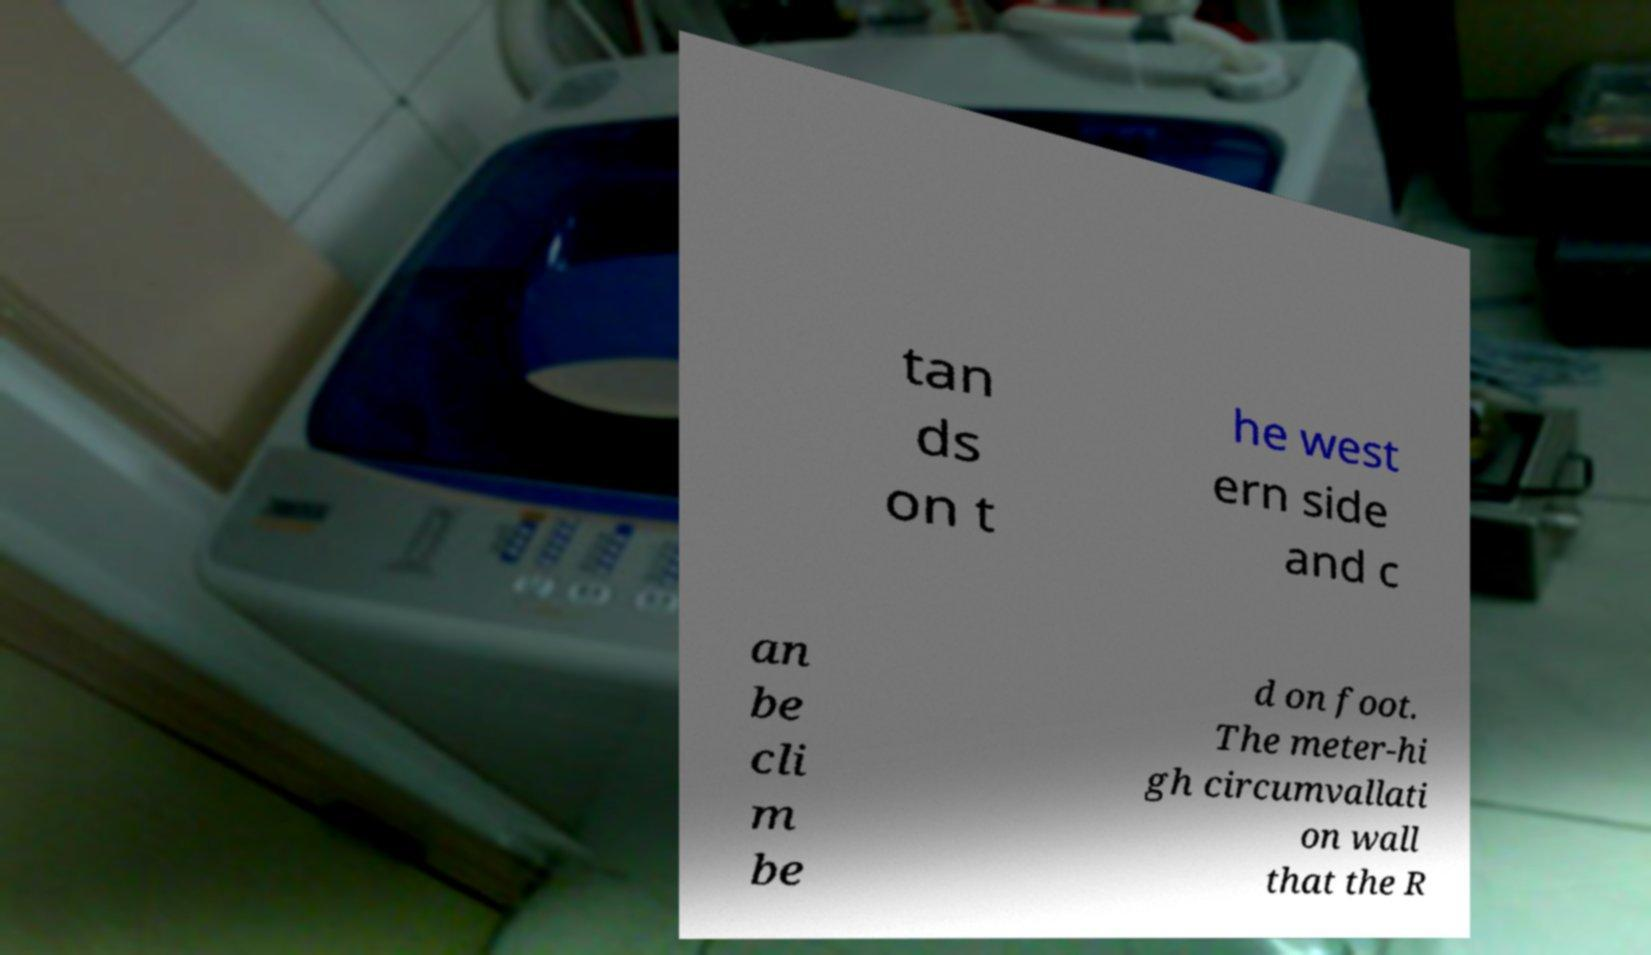Please read and relay the text visible in this image. What does it say? tan ds on t he west ern side and c an be cli m be d on foot. The meter-hi gh circumvallati on wall that the R 